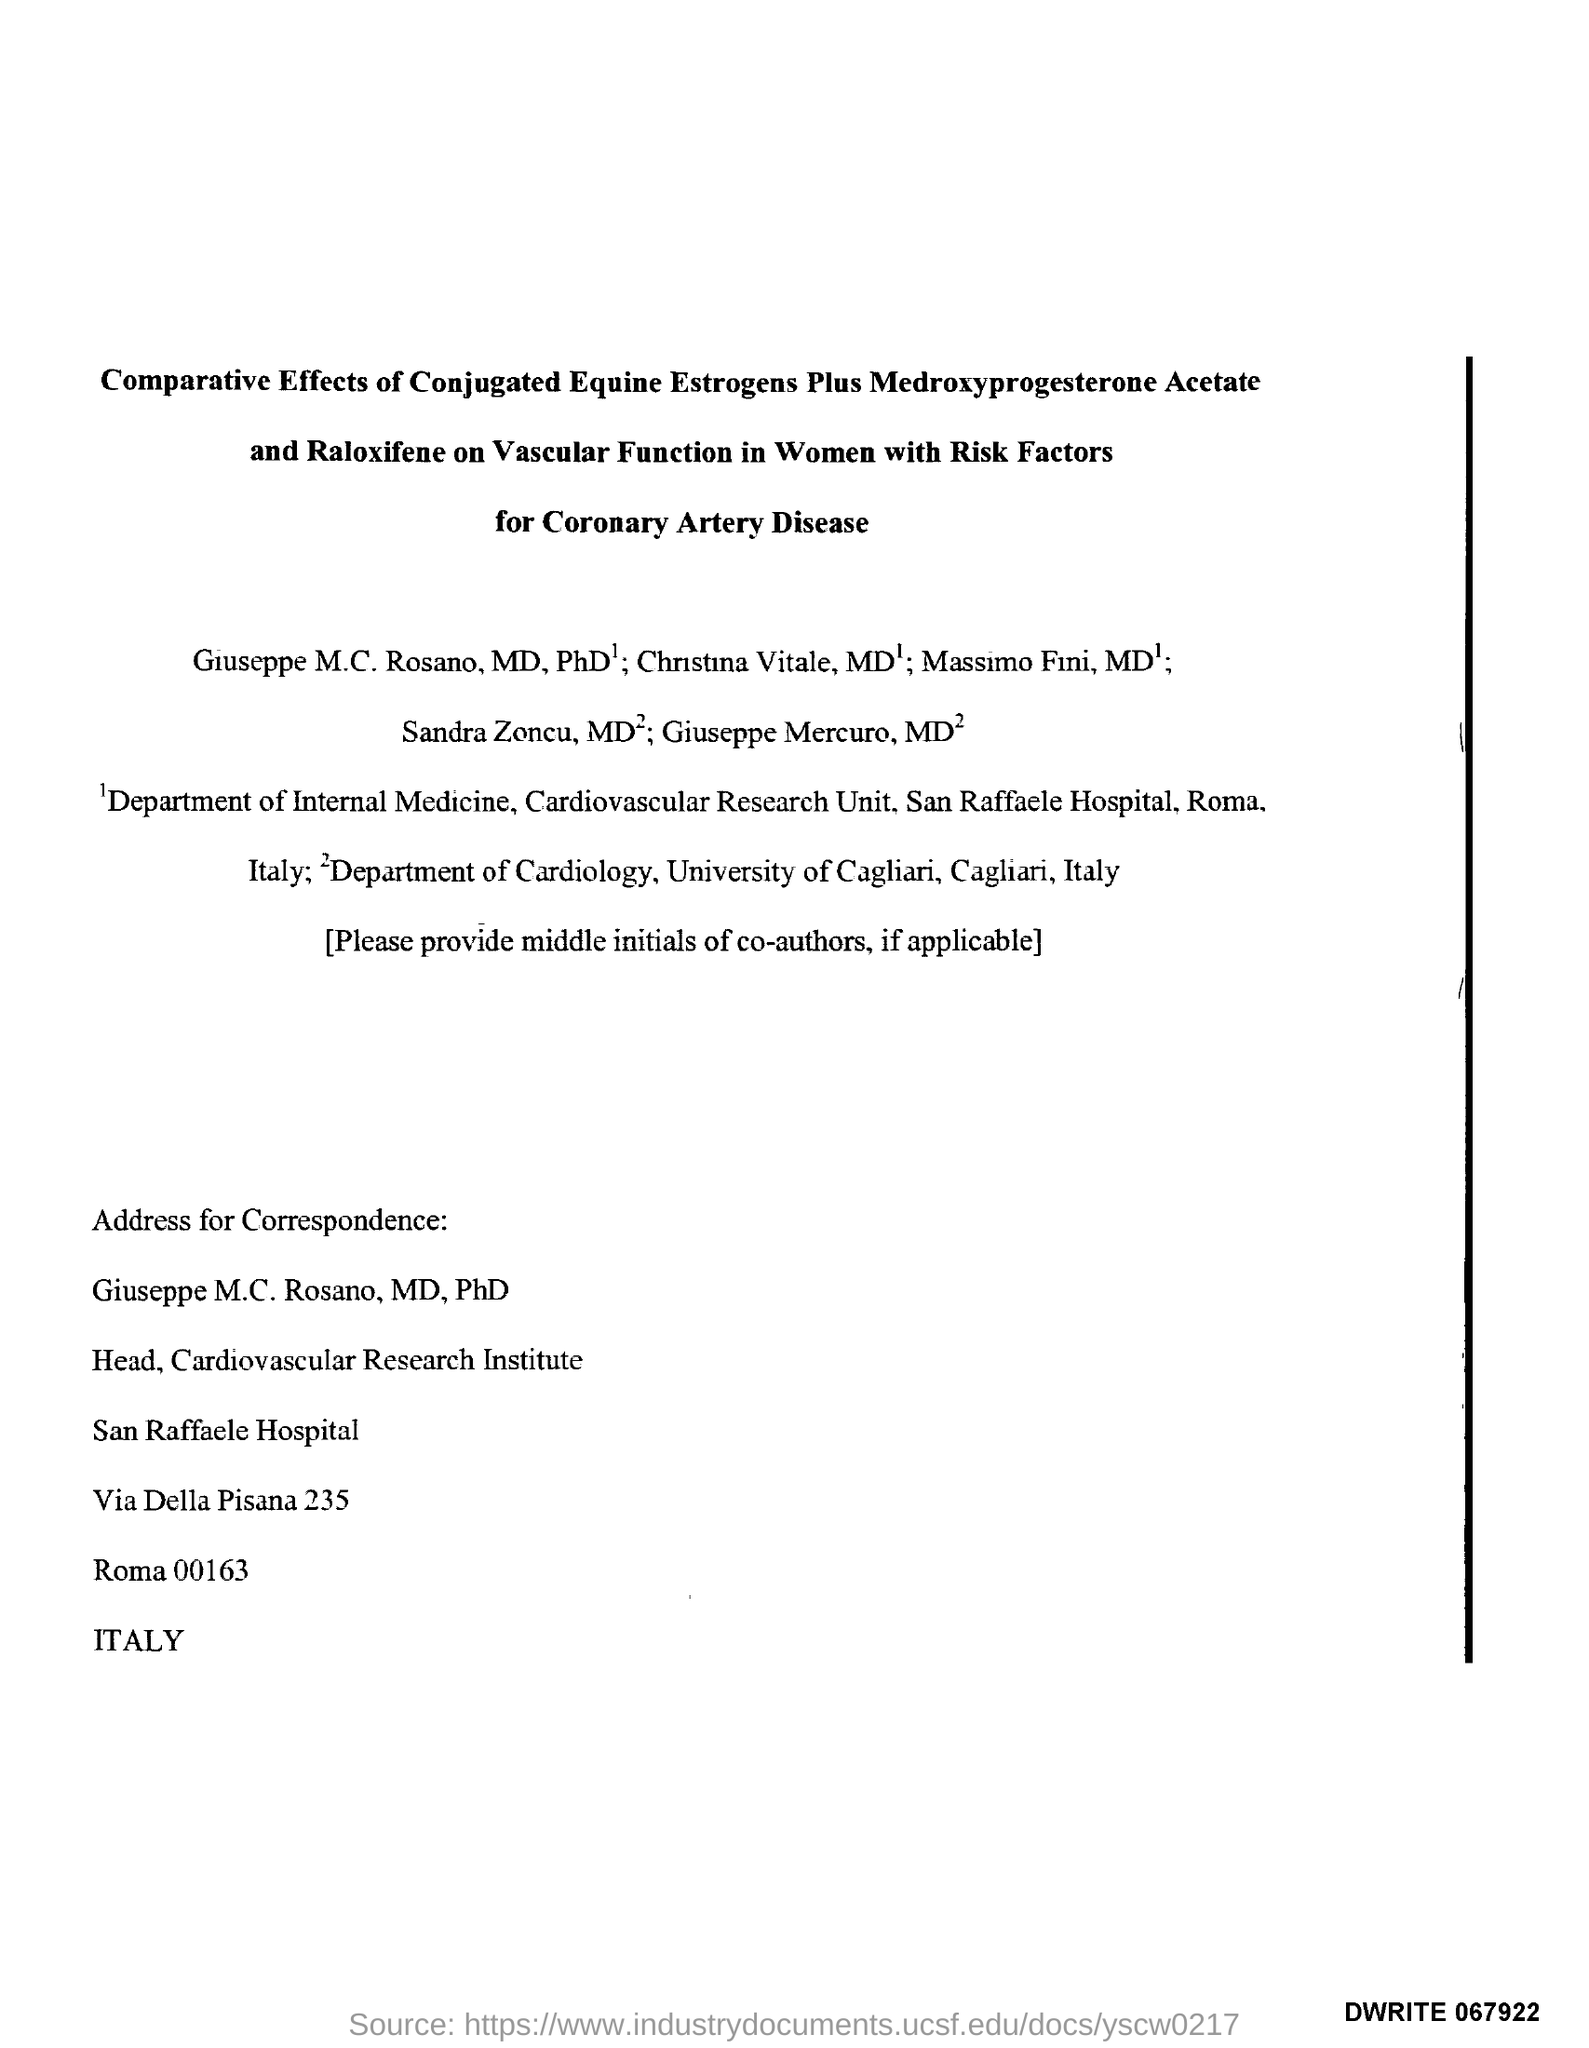What is the designation of Giuseppe M.C. Rosano, MD, PhD?
Make the answer very short. Head, Cardiovascular Research Institute. 